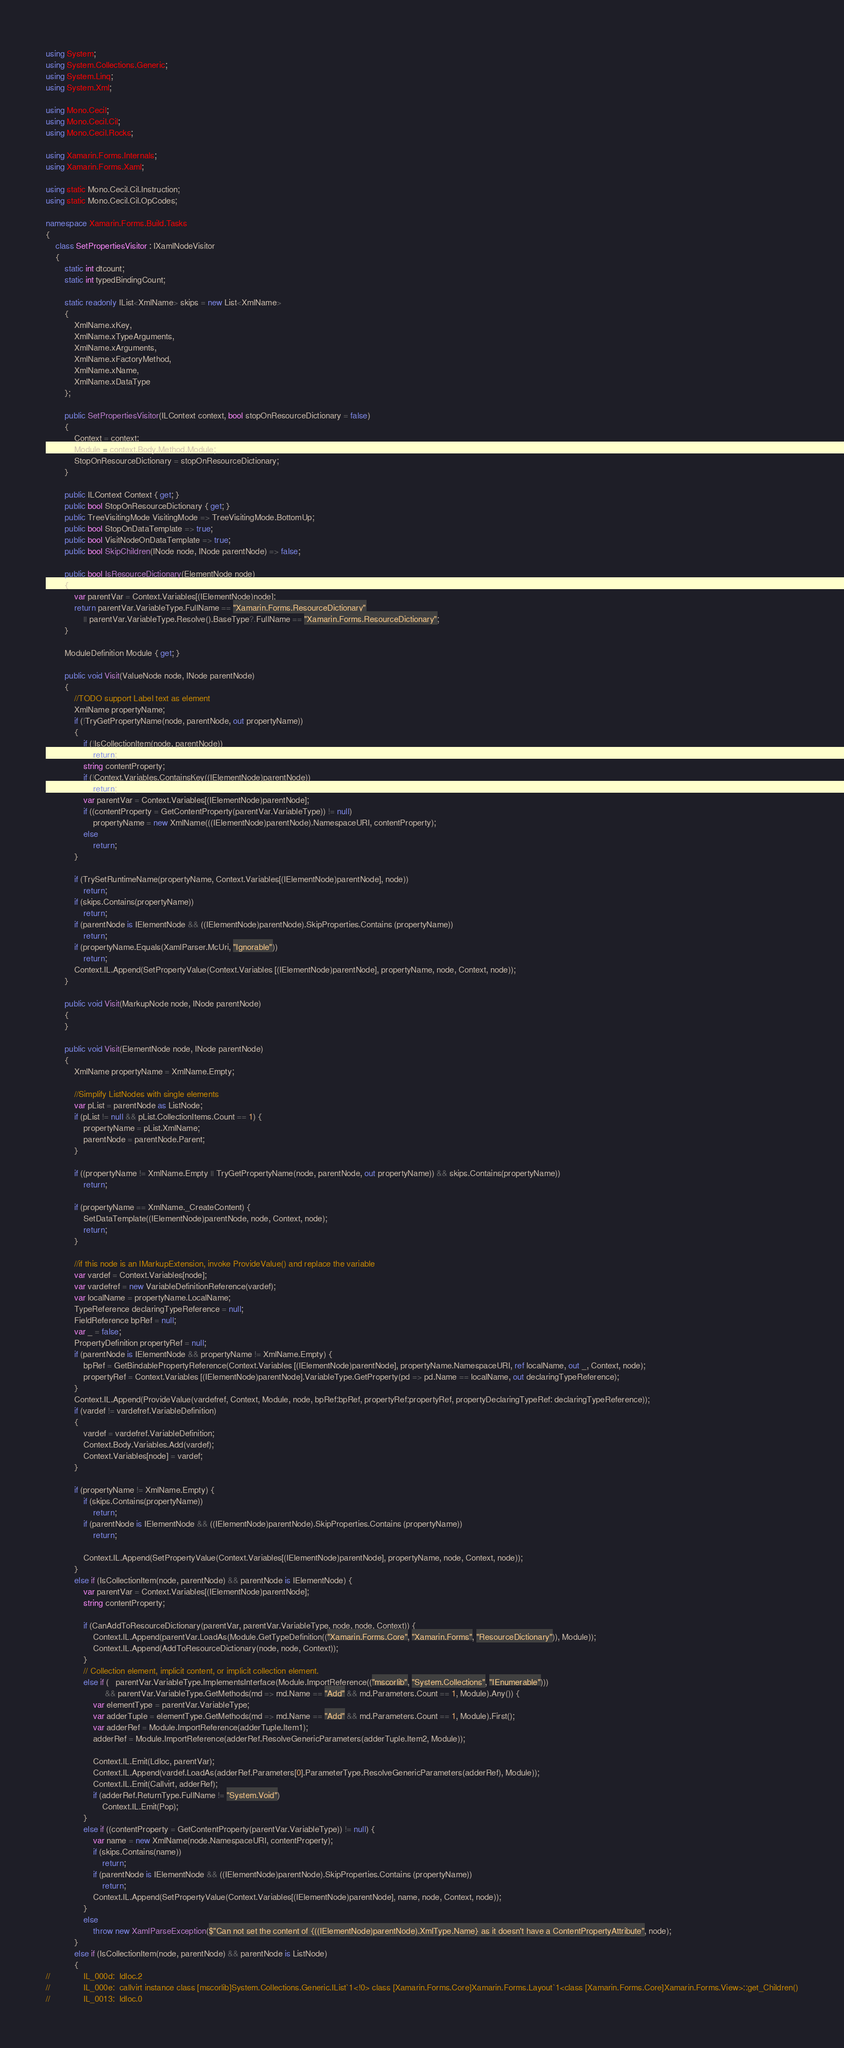<code> <loc_0><loc_0><loc_500><loc_500><_C#_>using System;
using System.Collections.Generic;
using System.Linq;
using System.Xml;

using Mono.Cecil;
using Mono.Cecil.Cil;
using Mono.Cecil.Rocks;

using Xamarin.Forms.Internals;
using Xamarin.Forms.Xaml;

using static Mono.Cecil.Cil.Instruction;
using static Mono.Cecil.Cil.OpCodes;

namespace Xamarin.Forms.Build.Tasks
{
	class SetPropertiesVisitor : IXamlNodeVisitor
	{
		static int dtcount;
		static int typedBindingCount;

		static readonly IList<XmlName> skips = new List<XmlName>
		{
			XmlName.xKey,
			XmlName.xTypeArguments,
			XmlName.xArguments,
			XmlName.xFactoryMethod,
			XmlName.xName,
			XmlName.xDataType
		};

		public SetPropertiesVisitor(ILContext context, bool stopOnResourceDictionary = false)
		{
			Context = context;
			Module = context.Body.Method.Module;
			StopOnResourceDictionary = stopOnResourceDictionary;
		}

		public ILContext Context { get; }
		public bool StopOnResourceDictionary { get; }
		public TreeVisitingMode VisitingMode => TreeVisitingMode.BottomUp;
		public bool StopOnDataTemplate => true;
		public bool VisitNodeOnDataTemplate => true;
		public bool SkipChildren(INode node, INode parentNode) => false;

		public bool IsResourceDictionary(ElementNode node)
		{
			var parentVar = Context.Variables[(IElementNode)node];
			return parentVar.VariableType.FullName == "Xamarin.Forms.ResourceDictionary"
				|| parentVar.VariableType.Resolve().BaseType?.FullName == "Xamarin.Forms.ResourceDictionary";
		}

		ModuleDefinition Module { get; }

		public void Visit(ValueNode node, INode parentNode)
		{
			//TODO support Label text as element
			XmlName propertyName;
			if (!TryGetPropertyName(node, parentNode, out propertyName))
			{
				if (!IsCollectionItem(node, parentNode))
					return;
				string contentProperty;
				if (!Context.Variables.ContainsKey((IElementNode)parentNode))
					return;
				var parentVar = Context.Variables[(IElementNode)parentNode];
				if ((contentProperty = GetContentProperty(parentVar.VariableType)) != null)
					propertyName = new XmlName(((IElementNode)parentNode).NamespaceURI, contentProperty);
				else
					return;
			}

			if (TrySetRuntimeName(propertyName, Context.Variables[(IElementNode)parentNode], node))
				return;
			if (skips.Contains(propertyName))
				return;
			if (parentNode is IElementNode && ((IElementNode)parentNode).SkipProperties.Contains (propertyName))
				return;
			if (propertyName.Equals(XamlParser.McUri, "Ignorable"))
				return;
			Context.IL.Append(SetPropertyValue(Context.Variables [(IElementNode)parentNode], propertyName, node, Context, node));
		}

		public void Visit(MarkupNode node, INode parentNode)
		{
		}

		public void Visit(ElementNode node, INode parentNode)
		{
			XmlName propertyName = XmlName.Empty;

			//Simplify ListNodes with single elements
			var pList = parentNode as ListNode;
			if (pList != null && pList.CollectionItems.Count == 1) {
				propertyName = pList.XmlName;
				parentNode = parentNode.Parent;
			}

			if ((propertyName != XmlName.Empty || TryGetPropertyName(node, parentNode, out propertyName)) && skips.Contains(propertyName))
				return;

			if (propertyName == XmlName._CreateContent) {
				SetDataTemplate((IElementNode)parentNode, node, Context, node);
				return;
			}

			//if this node is an IMarkupExtension, invoke ProvideValue() and replace the variable
			var vardef = Context.Variables[node];
			var vardefref = new VariableDefinitionReference(vardef);
			var localName = propertyName.LocalName;
			TypeReference declaringTypeReference = null;
			FieldReference bpRef = null;
			var _ = false;
			PropertyDefinition propertyRef = null;
			if (parentNode is IElementNode && propertyName != XmlName.Empty) {
				bpRef = GetBindablePropertyReference(Context.Variables [(IElementNode)parentNode], propertyName.NamespaceURI, ref localName, out _, Context, node);
				propertyRef = Context.Variables [(IElementNode)parentNode].VariableType.GetProperty(pd => pd.Name == localName, out declaringTypeReference);
			}
			Context.IL.Append(ProvideValue(vardefref, Context, Module, node, bpRef:bpRef, propertyRef:propertyRef, propertyDeclaringTypeRef: declaringTypeReference));
			if (vardef != vardefref.VariableDefinition)
			{
				vardef = vardefref.VariableDefinition;
				Context.Body.Variables.Add(vardef);
				Context.Variables[node] = vardef;
			}

			if (propertyName != XmlName.Empty) {
				if (skips.Contains(propertyName))
					return;
				if (parentNode is IElementNode && ((IElementNode)parentNode).SkipProperties.Contains (propertyName))
					return;
				
				Context.IL.Append(SetPropertyValue(Context.Variables[(IElementNode)parentNode], propertyName, node, Context, node));
			}
			else if (IsCollectionItem(node, parentNode) && parentNode is IElementNode) {
				var parentVar = Context.Variables[(IElementNode)parentNode];
				string contentProperty;

				if (CanAddToResourceDictionary(parentVar, parentVar.VariableType, node, node, Context)) {
					Context.IL.Append(parentVar.LoadAs(Module.GetTypeDefinition(("Xamarin.Forms.Core", "Xamarin.Forms", "ResourceDictionary")), Module));
					Context.IL.Append(AddToResourceDictionary(node, node, Context));
				}
				// Collection element, implicit content, or implicit collection element.
				else if (   parentVar.VariableType.ImplementsInterface(Module.ImportReference(("mscorlib", "System.Collections", "IEnumerable")))
						 && parentVar.VariableType.GetMethods(md => md.Name == "Add" && md.Parameters.Count == 1, Module).Any()) {
					var elementType = parentVar.VariableType;
					var adderTuple = elementType.GetMethods(md => md.Name == "Add" && md.Parameters.Count == 1, Module).First();
					var adderRef = Module.ImportReference(adderTuple.Item1);
					adderRef = Module.ImportReference(adderRef.ResolveGenericParameters(adderTuple.Item2, Module));

					Context.IL.Emit(Ldloc, parentVar);
					Context.IL.Append(vardef.LoadAs(adderRef.Parameters[0].ParameterType.ResolveGenericParameters(adderRef), Module));
					Context.IL.Emit(Callvirt, adderRef);
					if (adderRef.ReturnType.FullName != "System.Void")
						Context.IL.Emit(Pop);
				}
				else if ((contentProperty = GetContentProperty(parentVar.VariableType)) != null) {
					var name = new XmlName(node.NamespaceURI, contentProperty);
					if (skips.Contains(name))
						return;
					if (parentNode is IElementNode && ((IElementNode)parentNode).SkipProperties.Contains (propertyName))
						return;
					Context.IL.Append(SetPropertyValue(Context.Variables[(IElementNode)parentNode], name, node, Context, node));
				}
				else
					throw new XamlParseException($"Can not set the content of {((IElementNode)parentNode).XmlType.Name} as it doesn't have a ContentPropertyAttribute", node);
			}
			else if (IsCollectionItem(node, parentNode) && parentNode is ListNode)
			{
//				IL_000d:  ldloc.2 
//				IL_000e:  callvirt instance class [mscorlib]System.Collections.Generic.IList`1<!0> class [Xamarin.Forms.Core]Xamarin.Forms.Layout`1<class [Xamarin.Forms.Core]Xamarin.Forms.View>::get_Children()
//				IL_0013:  ldloc.0 </code> 